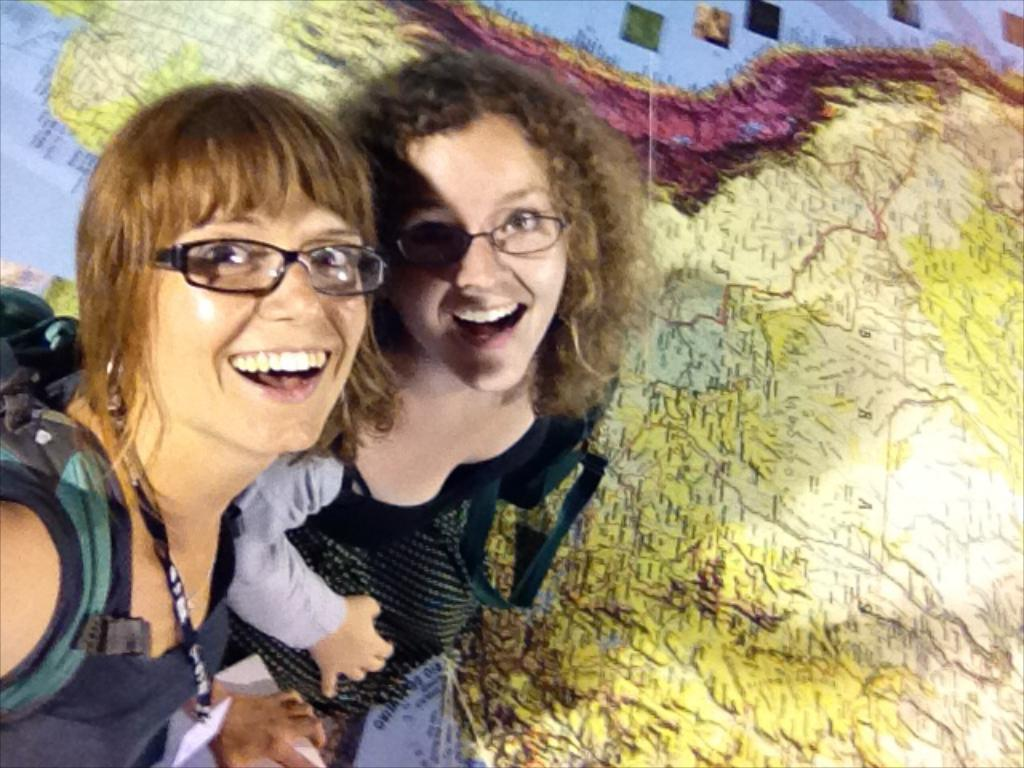How many people are present in the image? There are two persons in the image. What can be seen in the background of the image? There is a map in the background of the image. What type of meal is being prepared in the image? There is no indication of a meal being prepared in the image; it only features two persons and a map in the background. 